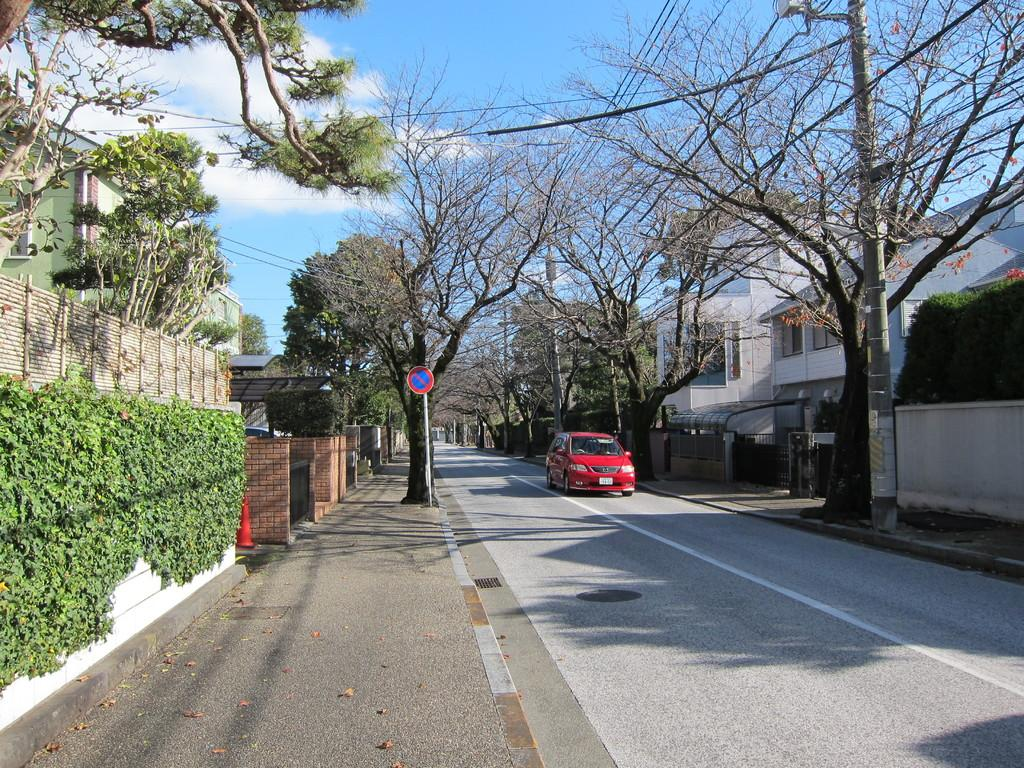What type of vehicle can be seen on the road in the image? There is a red color vehicle on the road in the image. What kind of structures are visible in the image? There are buildings with windows in the image. What type of vegetation is present in the image? Trees are present in the image. What kind of objects are attached to poles in the image? There are poles with lights and a pole with a sign board in the image. What type of popcorn is being sold at the town in the image? There is no mention of popcorn or a town in the image. 